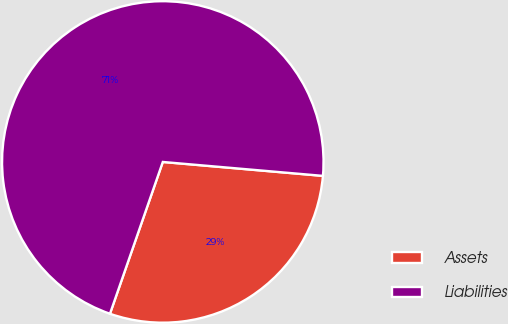<chart> <loc_0><loc_0><loc_500><loc_500><pie_chart><fcel>Assets<fcel>Liabilities<nl><fcel>28.95%<fcel>71.05%<nl></chart> 